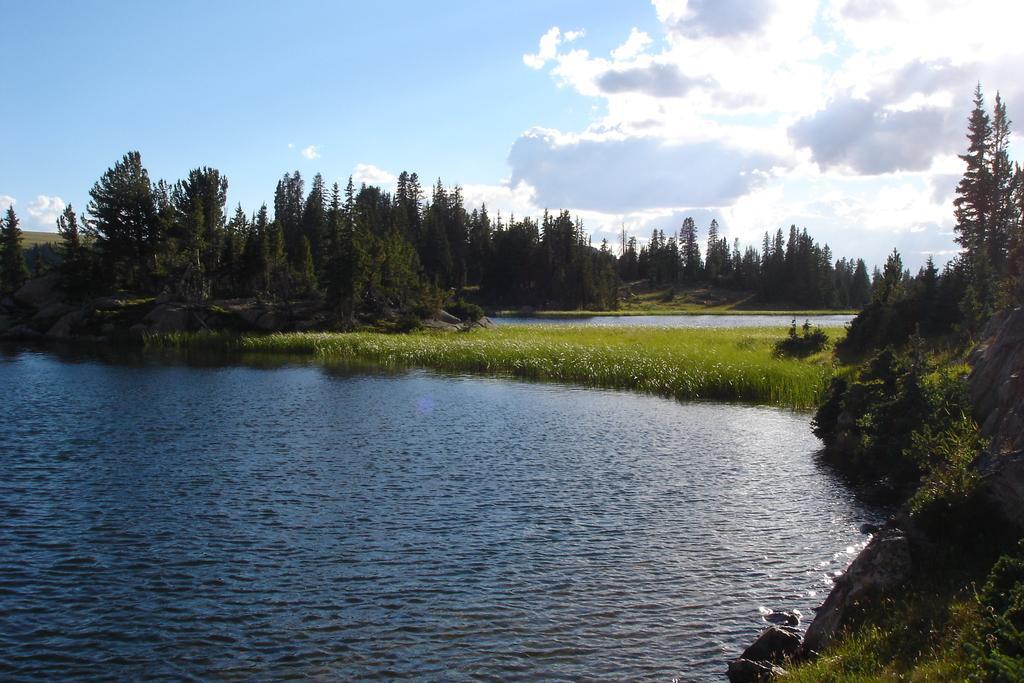Describe this image in one or two sentences. In this image we can see sky with clouds, trees, grass, rocks and water. 